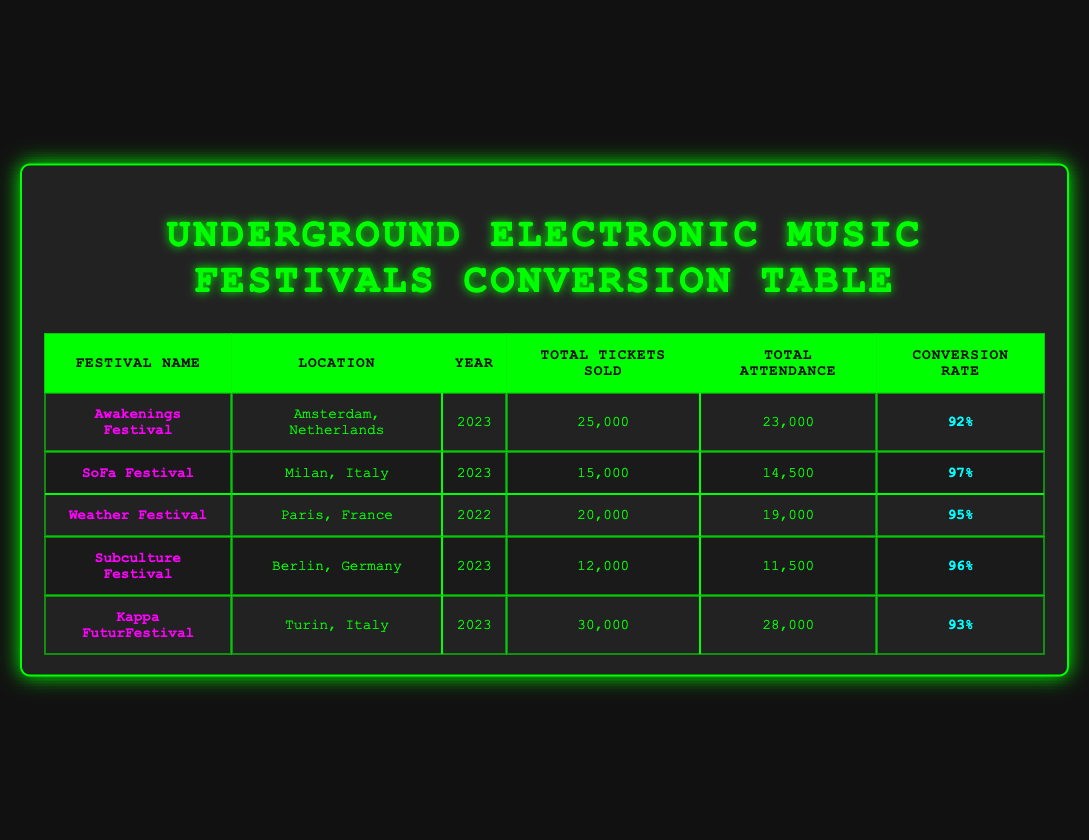What is the total number of tickets sold for the Kappa FuturFestival? The table lists that Kappa FuturFestival, located in Turin, Italy, sold a total of 30,000 tickets according to the provided data.
Answer: 30,000 Which festival had the highest total attendance in 2023? The festivals for 2023 include Awakenings Festival with 23,000 attendees, SoFa Festival with 14,500 attendees, Subculture Festival with 11,500 attendees, and Kappa FuturFestival with 28,000 attendees. Kappa FuturFestival had the highest attendance at 28,000.
Answer: Kappa FuturFestival What is the average conversion rate for the listed festivals in 2023? The conversion rates for the festivals in 2023 are 92% (Awakenings), 97% (SoFa), 96% (Subculture), and 93% (Kappa FuturFestival). To find the average, sum the conversion rates: 92 + 97 + 96 + 93 = 378. Dividing by the number of festivals (4) gives: 378/4 = 94.5%.
Answer: 94.5% Did the Weather Festival have more total tickets sold than the SoFa Festival? According to the table, the total tickets sold for Weather Festival was 20,000, and for SoFa Festival, it was 15,000. Since 20,000 is greater than 15,000, the statement is true.
Answer: Yes What is the difference in total attendance between Awakenings Festival and Subculture Festival? Awakenings Festival had a total attendance of 23,000 while Subculture Festival had 11,500. To find the difference, subtract Subculture's attendance from Awakenings: 23,000 - 11,500 = 11,500.
Answer: 11,500 Which festival had the lowest total tickets sold in 2022 and what was the number? The only festival listed for 2022 is Weather Festival, which sold a total of 20,000 tickets. Since it is the only festival for that year, it has the lowest by default.
Answer: Weather Festival, 20,000 How many total tickets were sold across all festivals listed for 2023? The total tickets sold for each festival in 2023 are Awakenings (25,000), SoFa (15,000), Subculture (12,000), and Kappa FuturFestival (30,000). Adding these up gives: 25,000 + 15,000 + 12,000 + 30,000 = 82,000.
Answer: 82,000 Is the total attendance for the Kappa FuturFestival greater than the total tickets sold for the Subculture Festival? Kappa FuturFestival had a total attendance of 28,000 while Subculture Festival had 12,000 total tickets sold. Since 28,000 is greater than 12,000, this statement is true.
Answer: Yes 